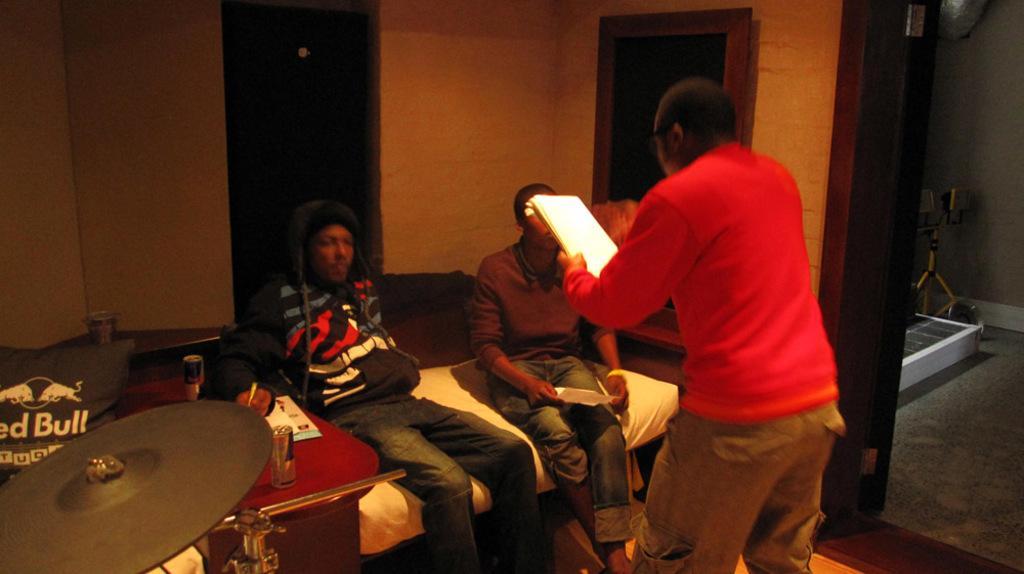Describe this image in one or two sentences. In this image a person wearing a red top is holding a book in his hand. Before him two persons are sitting on the sofa. Beside the sofa there is a table having few objects on it. Left bottom there is a musical instrument. Behind it there is a cushion. Background there is a wall. Right side there are few objects on the floor. 